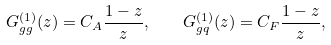<formula> <loc_0><loc_0><loc_500><loc_500>G _ { g g } ^ { ( 1 ) } ( z ) = C _ { A } \frac { 1 - z } { z } , \quad G _ { g q } ^ { ( 1 ) } ( z ) = C _ { F } \frac { 1 - z } { z } ,</formula> 